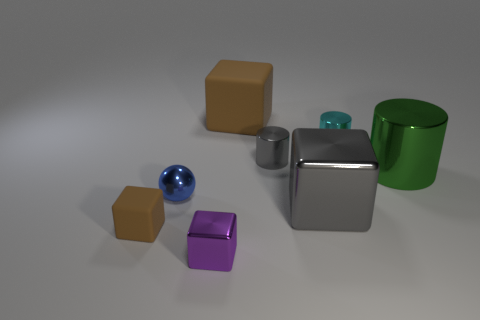There is a cyan object that is right of the brown object to the right of the tiny block that is to the right of the tiny rubber object; what shape is it?
Provide a short and direct response. Cylinder. The small object that is left of the purple thing and right of the small brown cube has what shape?
Make the answer very short. Sphere. There is a rubber object that is left of the matte cube that is behind the small brown block; how many brown matte objects are right of it?
Offer a terse response. 1. What size is the green object that is the same shape as the cyan metal object?
Make the answer very short. Large. Do the big object right of the tiny cyan metal cylinder and the cyan cylinder have the same material?
Provide a short and direct response. Yes. There is another big object that is the same shape as the large brown object; what color is it?
Offer a very short reply. Gray. What number of other objects are there of the same color as the big cylinder?
Keep it short and to the point. 0. There is a brown rubber object behind the cyan cylinder; does it have the same shape as the large shiny thing behind the tiny blue shiny object?
Make the answer very short. No. What number of cylinders are small purple metallic objects or metal things?
Provide a succinct answer. 3. Are there fewer large brown blocks that are in front of the blue object than gray cylinders?
Keep it short and to the point. Yes. 